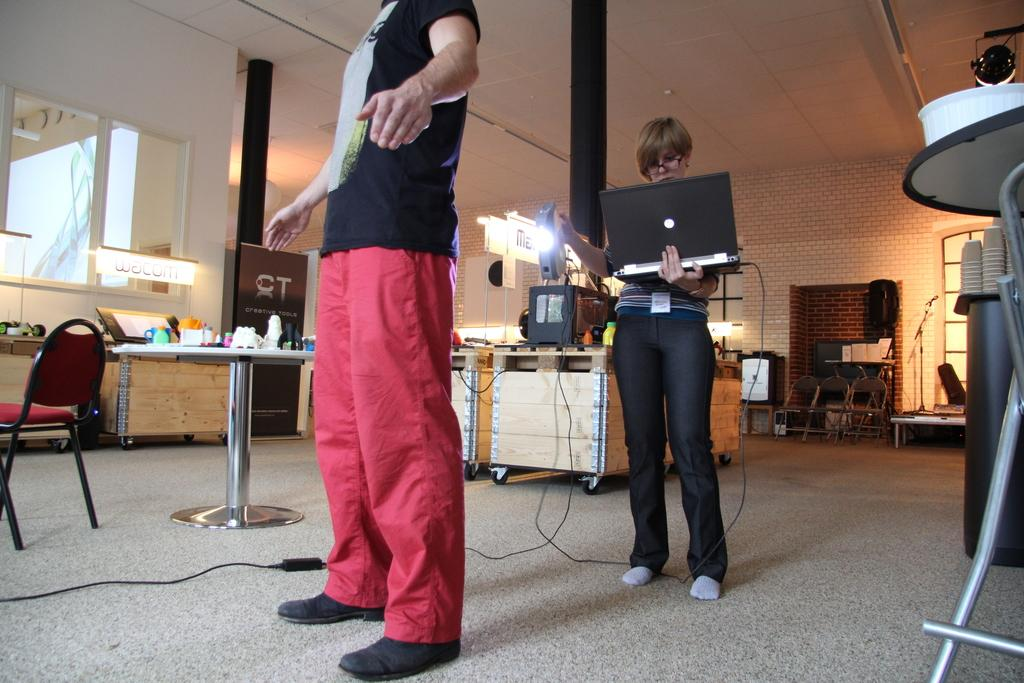What is the main activity of the people in the image? The people in the image are standing. What object is the woman holding in the image? The woman is holding a laptop and a torch. Can you tell me how many times the woman has been bitten by a snake in the image? There is no mention of a snake or any biting incident in the image. 